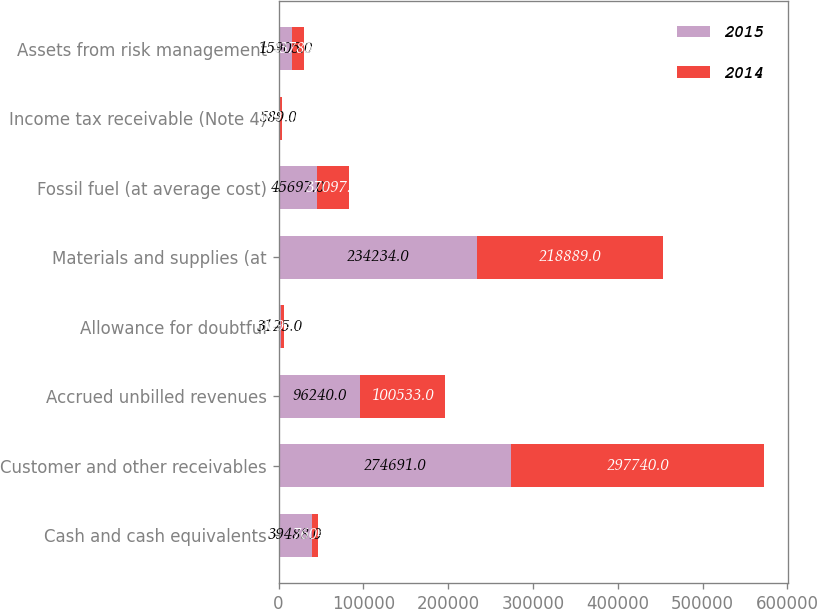Convert chart to OTSL. <chart><loc_0><loc_0><loc_500><loc_500><stacked_bar_chart><ecel><fcel>Cash and cash equivalents<fcel>Customer and other receivables<fcel>Accrued unbilled revenues<fcel>Allowance for doubtful<fcel>Materials and supplies (at<fcel>Fossil fuel (at average cost)<fcel>Income tax receivable (Note 4)<fcel>Assets from risk management<nl><fcel>2015<fcel>39488<fcel>274691<fcel>96240<fcel>3125<fcel>234234<fcel>45697<fcel>589<fcel>15905<nl><fcel>2014<fcel>7604<fcel>297740<fcel>100533<fcel>3094<fcel>218889<fcel>37097<fcel>3098<fcel>13785<nl></chart> 